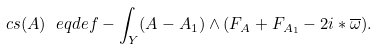Convert formula to latex. <formula><loc_0><loc_0><loc_500><loc_500>c s ( A ) \ e q d e f - \int _ { Y } ( A - A _ { 1 } ) \wedge ( F _ { A } + F _ { A _ { 1 } } - 2 i * \overline { \omega } ) .</formula> 